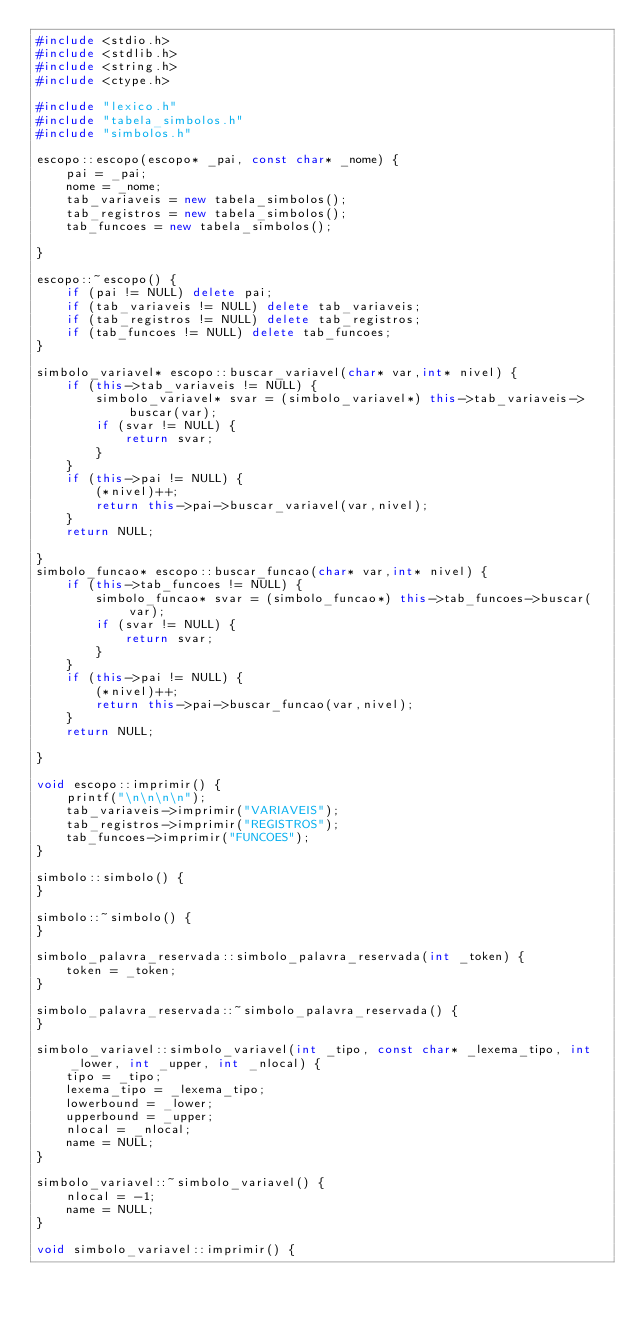<code> <loc_0><loc_0><loc_500><loc_500><_C++_>#include <stdio.h>
#include <stdlib.h>
#include <string.h>
#include <ctype.h>

#include "lexico.h"
#include "tabela_simbolos.h"
#include "simbolos.h"

escopo::escopo(escopo* _pai, const char* _nome) {
    pai = _pai;
    nome = _nome;
    tab_variaveis = new tabela_simbolos();
    tab_registros = new tabela_simbolos();
    tab_funcoes = new tabela_simbolos();

}

escopo::~escopo() {
    if (pai != NULL) delete pai;
    if (tab_variaveis != NULL) delete tab_variaveis;
    if (tab_registros != NULL) delete tab_registros;
    if (tab_funcoes != NULL) delete tab_funcoes;
}

simbolo_variavel* escopo::buscar_variavel(char* var,int* nivel) {
    if (this->tab_variaveis != NULL) {
        simbolo_variavel* svar = (simbolo_variavel*) this->tab_variaveis->buscar(var);
        if (svar != NULL) {
            return svar;
        }
    }
    if (this->pai != NULL) {
        (*nivel)++;
        return this->pai->buscar_variavel(var,nivel);
    }
    return NULL;

}
simbolo_funcao* escopo::buscar_funcao(char* var,int* nivel) {
    if (this->tab_funcoes != NULL) {
        simbolo_funcao* svar = (simbolo_funcao*) this->tab_funcoes->buscar(var);
        if (svar != NULL) {
            return svar;
        }
    }
    if (this->pai != NULL) {
        (*nivel)++;
        return this->pai->buscar_funcao(var,nivel);
    }
    return NULL;

}

void escopo::imprimir() {
    printf("\n\n\n\n");
    tab_variaveis->imprimir("VARIAVEIS");
    tab_registros->imprimir("REGISTROS");
    tab_funcoes->imprimir("FUNCOES");
}

simbolo::simbolo() {
}

simbolo::~simbolo() {
}

simbolo_palavra_reservada::simbolo_palavra_reservada(int _token) {
    token = _token;
}

simbolo_palavra_reservada::~simbolo_palavra_reservada() {
}

simbolo_variavel::simbolo_variavel(int _tipo, const char* _lexema_tipo, int _lower, int _upper, int _nlocal) {
    tipo = _tipo;
    lexema_tipo = _lexema_tipo;
    lowerbound = _lower;
    upperbound = _upper;
    nlocal = _nlocal;
    name = NULL;
}

simbolo_variavel::~simbolo_variavel() {
    nlocal = -1;
    name = NULL;
}

void simbolo_variavel::imprimir() {</code> 